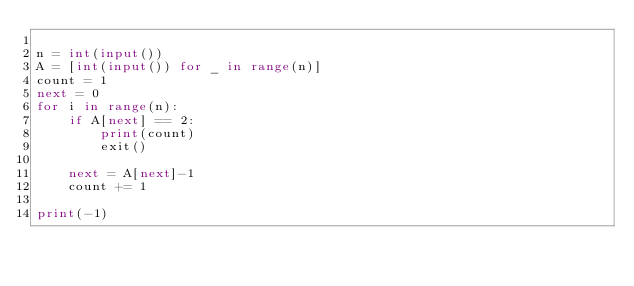Convert code to text. <code><loc_0><loc_0><loc_500><loc_500><_Python_>
n = int(input())
A = [int(input()) for _ in range(n)]
count = 1
next = 0
for i in range(n):
    if A[next] == 2:
        print(count)
        exit()

    next = A[next]-1
    count += 1

print(-1)</code> 